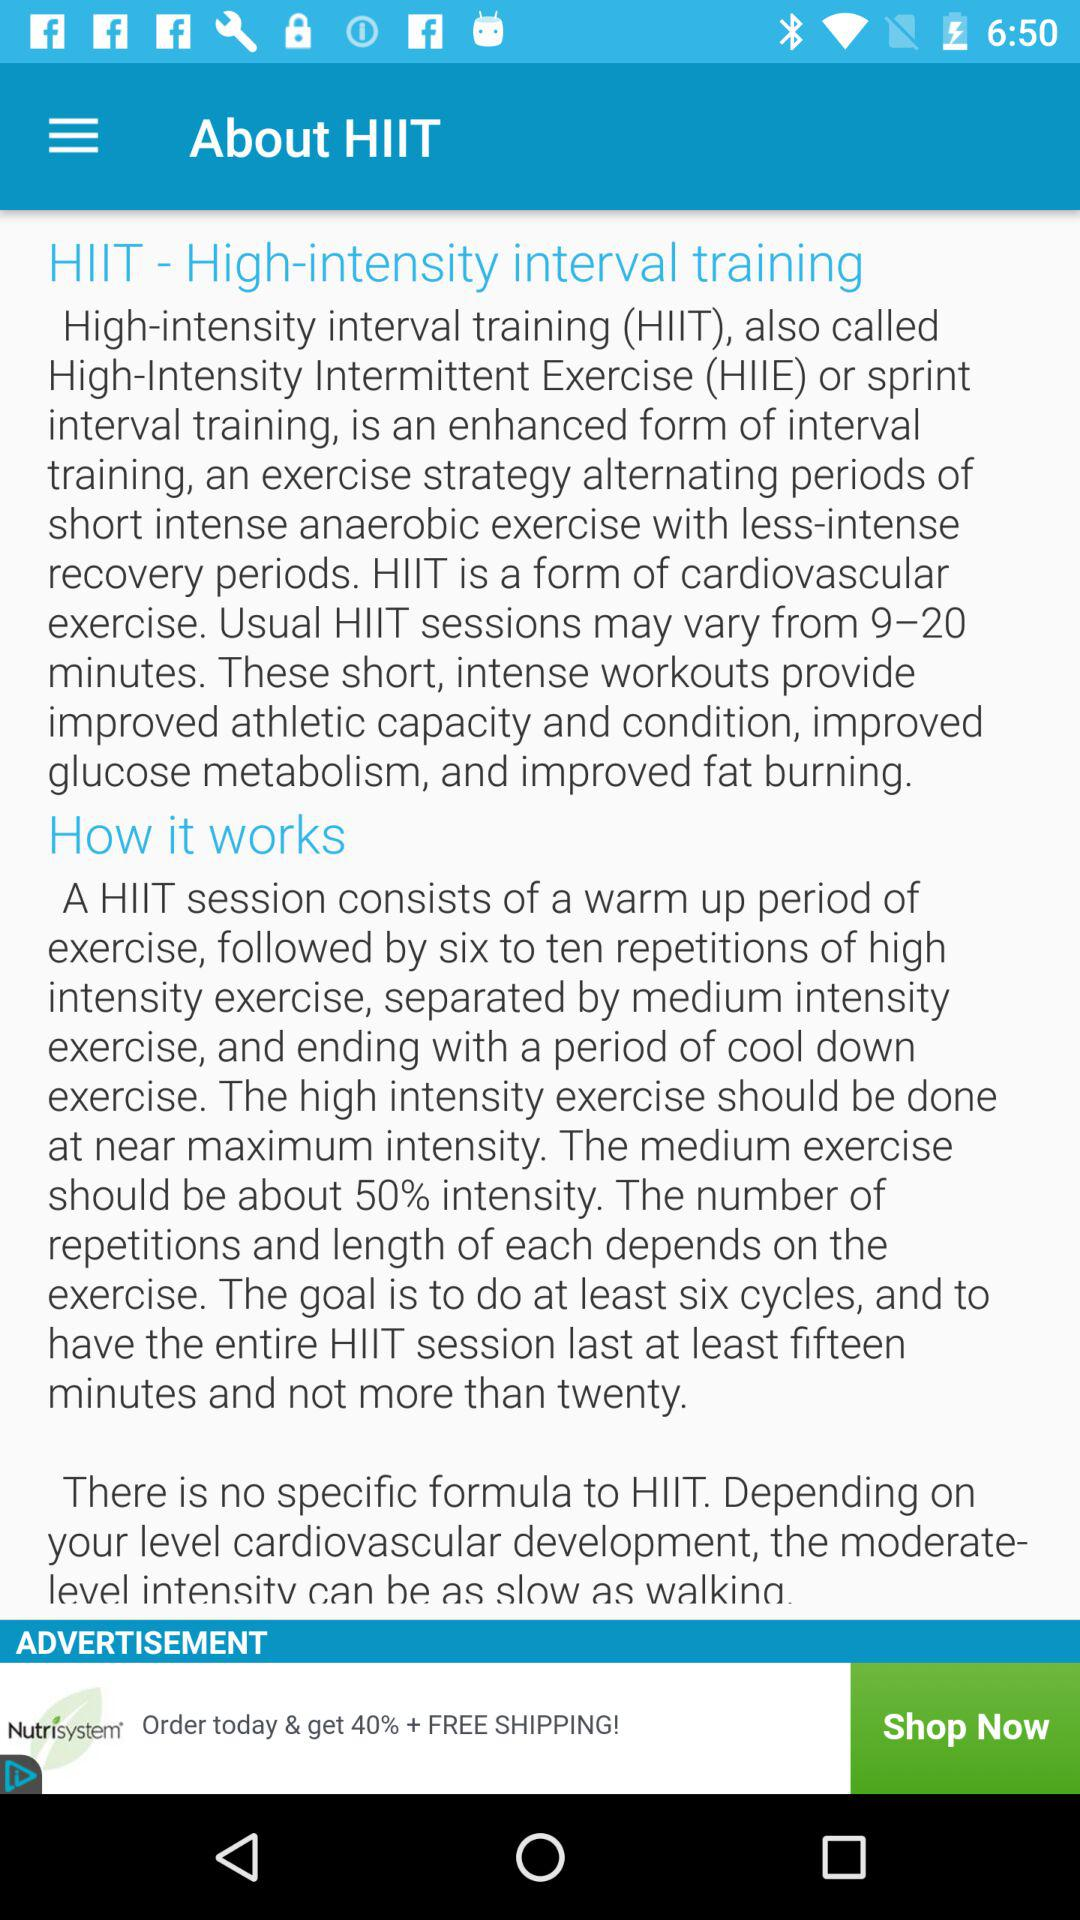What is the short form of "High-Intensity Intermittent Exercise"? The short form of "High-Intensity Intermittent Exercise" is HIIE. 